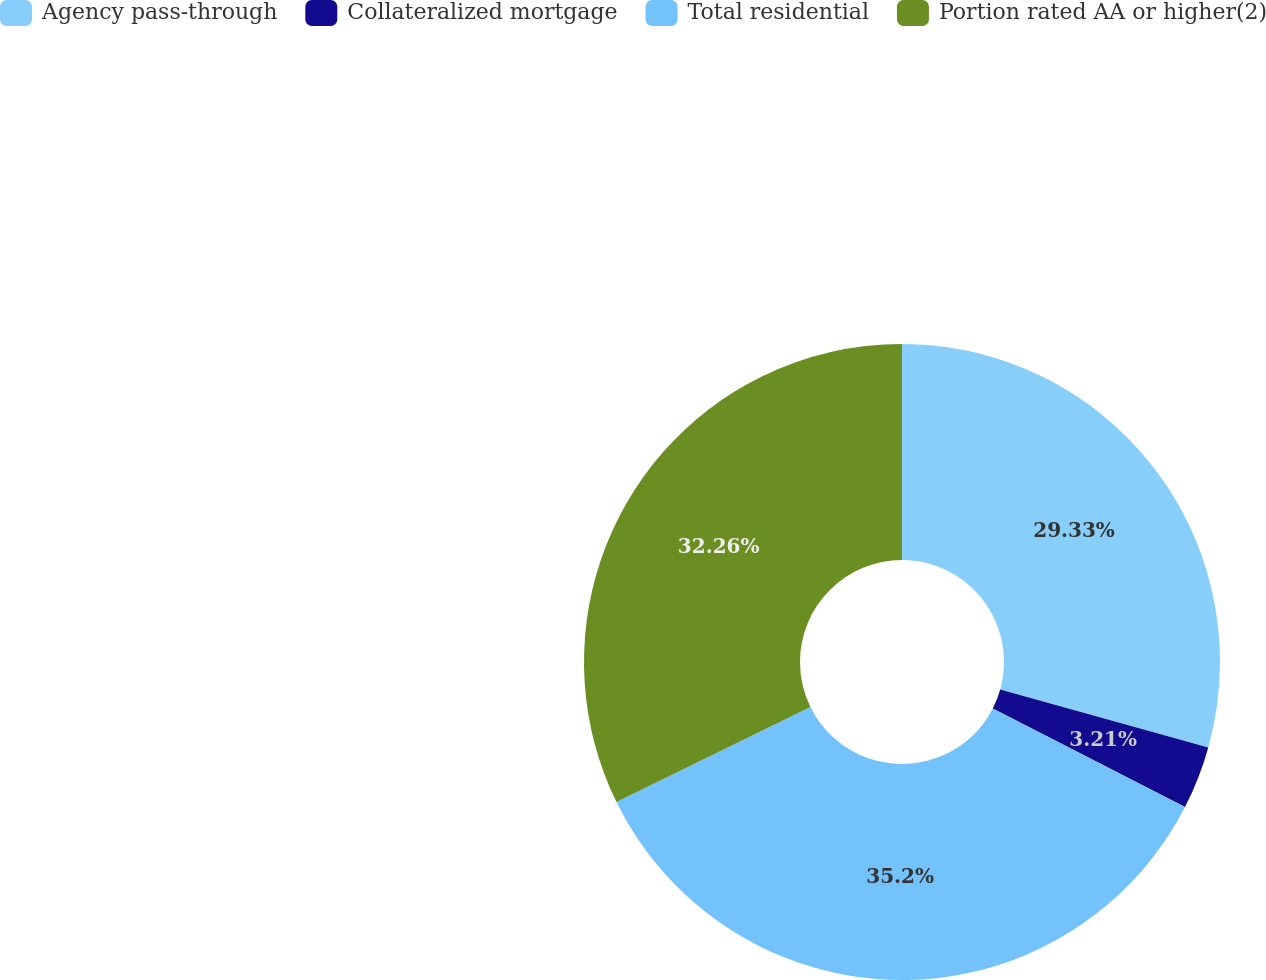<chart> <loc_0><loc_0><loc_500><loc_500><pie_chart><fcel>Agency pass-through<fcel>Collateralized mortgage<fcel>Total residential<fcel>Portion rated AA or higher(2)<nl><fcel>29.33%<fcel>3.21%<fcel>35.2%<fcel>32.26%<nl></chart> 